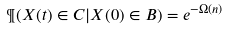<formula> <loc_0><loc_0><loc_500><loc_500>\P ( X ( t ) \in C | X ( 0 ) \in B ) = e ^ { - \Omega ( n ) }</formula> 